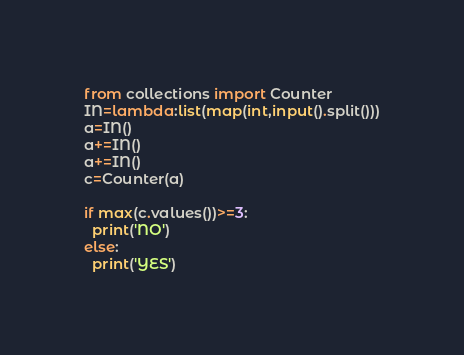Convert code to text. <code><loc_0><loc_0><loc_500><loc_500><_Python_>from collections import Counter
IN=lambda:list(map(int,input().split()))
a=IN()
a+=IN()
a+=IN()
c=Counter(a)

if max(c.values())>=3:
  print('NO')
else:
  print('YES')</code> 